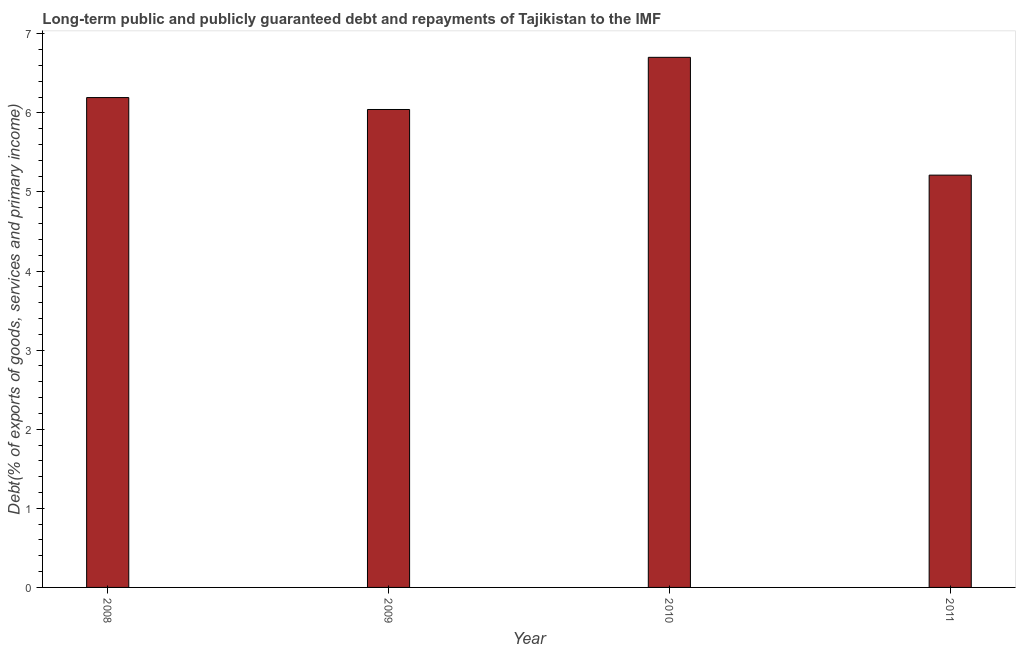Does the graph contain any zero values?
Your answer should be compact. No. What is the title of the graph?
Offer a very short reply. Long-term public and publicly guaranteed debt and repayments of Tajikistan to the IMF. What is the label or title of the X-axis?
Make the answer very short. Year. What is the label or title of the Y-axis?
Keep it short and to the point. Debt(% of exports of goods, services and primary income). What is the debt service in 2008?
Give a very brief answer. 6.19. Across all years, what is the maximum debt service?
Provide a short and direct response. 6.7. Across all years, what is the minimum debt service?
Provide a succinct answer. 5.21. In which year was the debt service maximum?
Offer a very short reply. 2010. What is the sum of the debt service?
Make the answer very short. 24.15. What is the difference between the debt service in 2008 and 2010?
Ensure brevity in your answer.  -0.51. What is the average debt service per year?
Offer a very short reply. 6.04. What is the median debt service?
Make the answer very short. 6.12. In how many years, is the debt service greater than 4.2 %?
Offer a terse response. 4. What is the ratio of the debt service in 2008 to that in 2010?
Keep it short and to the point. 0.92. Is the debt service in 2008 less than that in 2009?
Offer a very short reply. No. What is the difference between the highest and the second highest debt service?
Give a very brief answer. 0.51. Is the sum of the debt service in 2008 and 2011 greater than the maximum debt service across all years?
Provide a short and direct response. Yes. What is the difference between the highest and the lowest debt service?
Make the answer very short. 1.49. How many bars are there?
Provide a succinct answer. 4. What is the Debt(% of exports of goods, services and primary income) of 2008?
Provide a succinct answer. 6.19. What is the Debt(% of exports of goods, services and primary income) in 2009?
Give a very brief answer. 6.04. What is the Debt(% of exports of goods, services and primary income) of 2010?
Keep it short and to the point. 6.7. What is the Debt(% of exports of goods, services and primary income) in 2011?
Ensure brevity in your answer.  5.21. What is the difference between the Debt(% of exports of goods, services and primary income) in 2008 and 2009?
Provide a short and direct response. 0.15. What is the difference between the Debt(% of exports of goods, services and primary income) in 2008 and 2010?
Make the answer very short. -0.51. What is the difference between the Debt(% of exports of goods, services and primary income) in 2008 and 2011?
Offer a very short reply. 0.98. What is the difference between the Debt(% of exports of goods, services and primary income) in 2009 and 2010?
Ensure brevity in your answer.  -0.66. What is the difference between the Debt(% of exports of goods, services and primary income) in 2009 and 2011?
Provide a succinct answer. 0.83. What is the difference between the Debt(% of exports of goods, services and primary income) in 2010 and 2011?
Ensure brevity in your answer.  1.49. What is the ratio of the Debt(% of exports of goods, services and primary income) in 2008 to that in 2009?
Your answer should be compact. 1.02. What is the ratio of the Debt(% of exports of goods, services and primary income) in 2008 to that in 2010?
Ensure brevity in your answer.  0.92. What is the ratio of the Debt(% of exports of goods, services and primary income) in 2008 to that in 2011?
Your response must be concise. 1.19. What is the ratio of the Debt(% of exports of goods, services and primary income) in 2009 to that in 2010?
Offer a terse response. 0.9. What is the ratio of the Debt(% of exports of goods, services and primary income) in 2009 to that in 2011?
Offer a very short reply. 1.16. What is the ratio of the Debt(% of exports of goods, services and primary income) in 2010 to that in 2011?
Offer a very short reply. 1.29. 